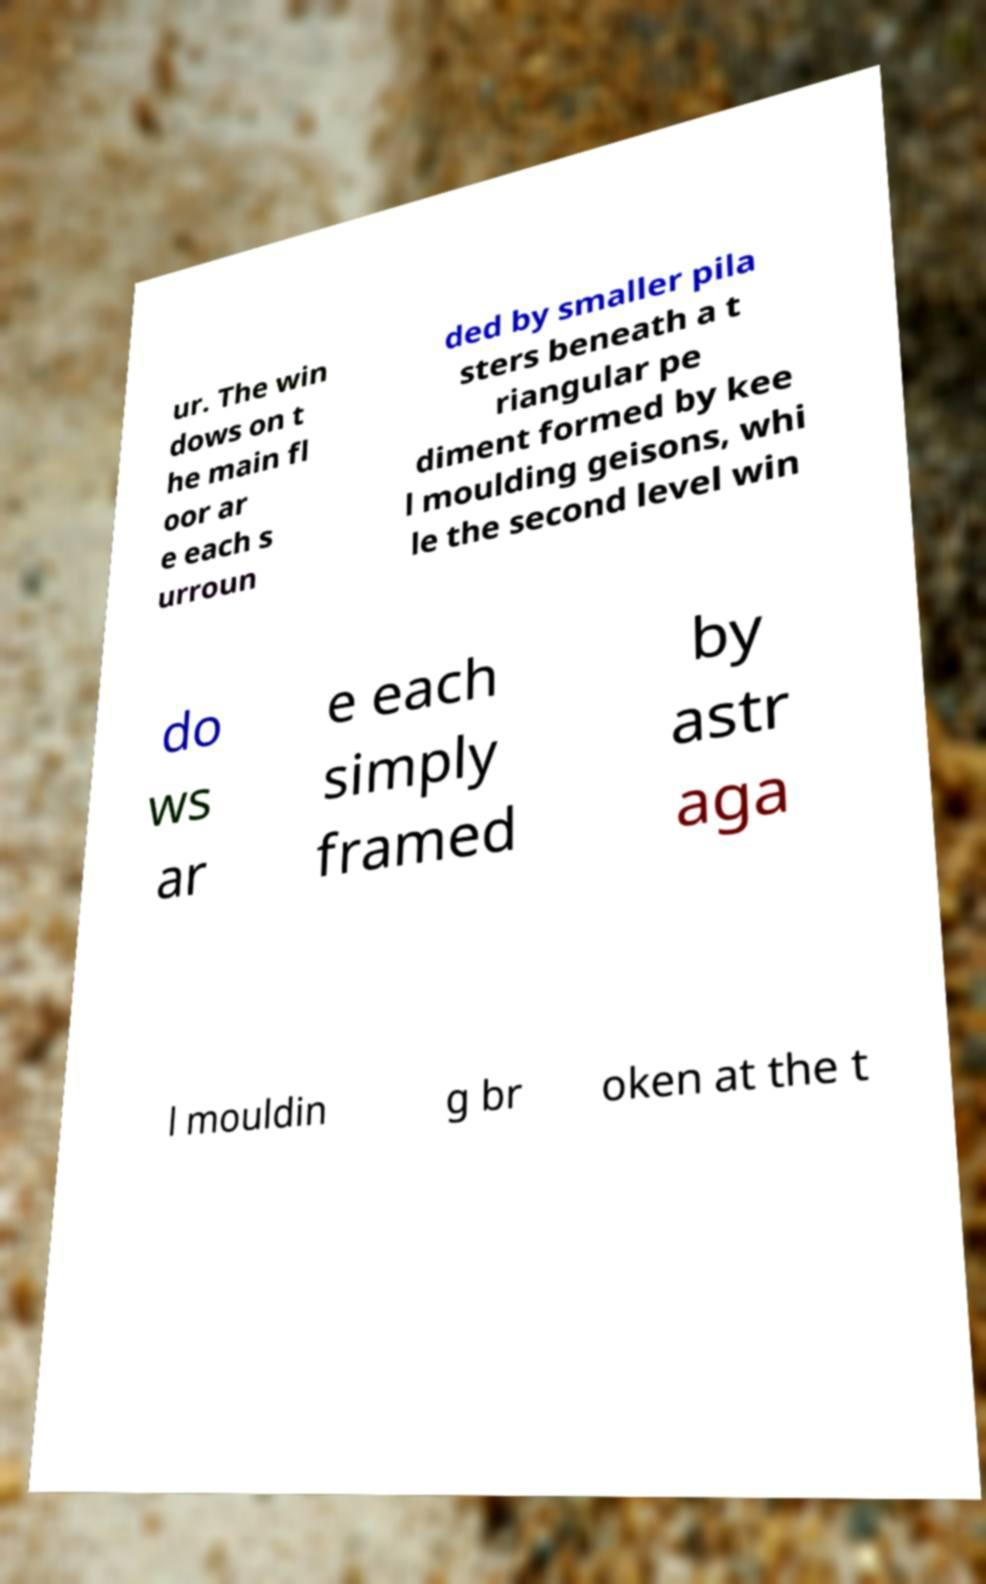There's text embedded in this image that I need extracted. Can you transcribe it verbatim? ur. The win dows on t he main fl oor ar e each s urroun ded by smaller pila sters beneath a t riangular pe diment formed by kee l moulding geisons, whi le the second level win do ws ar e each simply framed by astr aga l mouldin g br oken at the t 